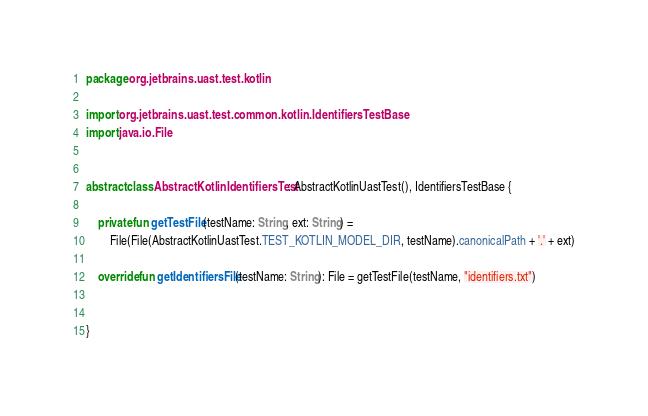Convert code to text. <code><loc_0><loc_0><loc_500><loc_500><_Kotlin_>package org.jetbrains.uast.test.kotlin

import org.jetbrains.uast.test.common.kotlin.IdentifiersTestBase
import java.io.File


abstract class AbstractKotlinIdentifiersTest : AbstractKotlinUastTest(), IdentifiersTestBase {

    private fun getTestFile(testName: String, ext: String) =
        File(File(AbstractKotlinUastTest.TEST_KOTLIN_MODEL_DIR, testName).canonicalPath + '.' + ext)

    override fun getIdentifiersFile(testName: String): File = getTestFile(testName, "identifiers.txt")


}</code> 